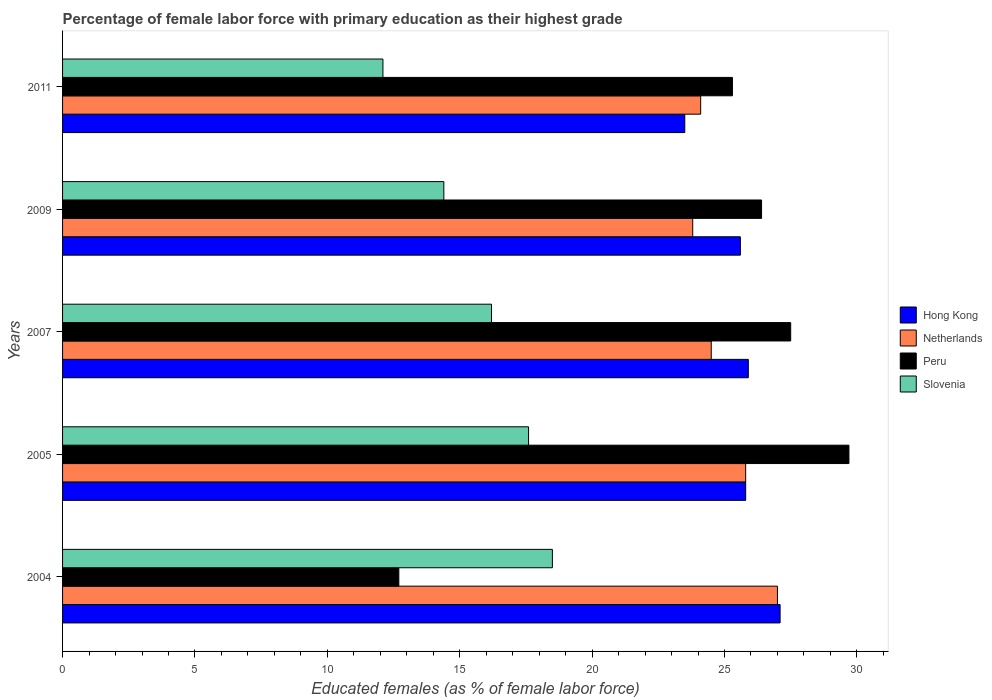How many different coloured bars are there?
Give a very brief answer. 4. How many groups of bars are there?
Your response must be concise. 5. Are the number of bars per tick equal to the number of legend labels?
Provide a short and direct response. Yes. Are the number of bars on each tick of the Y-axis equal?
Provide a succinct answer. Yes. How many bars are there on the 2nd tick from the bottom?
Your answer should be compact. 4. What is the percentage of female labor force with primary education in Netherlands in 2009?
Keep it short and to the point. 23.8. Across all years, what is the maximum percentage of female labor force with primary education in Peru?
Your answer should be compact. 29.7. Across all years, what is the minimum percentage of female labor force with primary education in Netherlands?
Your answer should be compact. 23.8. In which year was the percentage of female labor force with primary education in Slovenia minimum?
Provide a short and direct response. 2011. What is the total percentage of female labor force with primary education in Peru in the graph?
Ensure brevity in your answer.  121.6. What is the difference between the percentage of female labor force with primary education in Peru in 2004 and that in 2011?
Give a very brief answer. -12.6. What is the difference between the percentage of female labor force with primary education in Netherlands in 2005 and the percentage of female labor force with primary education in Hong Kong in 2007?
Your answer should be compact. -0.1. What is the average percentage of female labor force with primary education in Hong Kong per year?
Keep it short and to the point. 25.58. In the year 2009, what is the difference between the percentage of female labor force with primary education in Slovenia and percentage of female labor force with primary education in Hong Kong?
Your answer should be compact. -11.2. What is the ratio of the percentage of female labor force with primary education in Peru in 2005 to that in 2009?
Your response must be concise. 1.13. Is the difference between the percentage of female labor force with primary education in Slovenia in 2004 and 2005 greater than the difference between the percentage of female labor force with primary education in Hong Kong in 2004 and 2005?
Make the answer very short. No. What is the difference between the highest and the second highest percentage of female labor force with primary education in Hong Kong?
Keep it short and to the point. 1.2. What is the difference between the highest and the lowest percentage of female labor force with primary education in Netherlands?
Offer a terse response. 3.2. Is the sum of the percentage of female labor force with primary education in Peru in 2005 and 2009 greater than the maximum percentage of female labor force with primary education in Slovenia across all years?
Keep it short and to the point. Yes. What does the 2nd bar from the top in 2011 represents?
Your answer should be compact. Peru. What does the 4th bar from the bottom in 2005 represents?
Keep it short and to the point. Slovenia. Is it the case that in every year, the sum of the percentage of female labor force with primary education in Peru and percentage of female labor force with primary education in Netherlands is greater than the percentage of female labor force with primary education in Hong Kong?
Ensure brevity in your answer.  Yes. How many bars are there?
Give a very brief answer. 20. What is the difference between two consecutive major ticks on the X-axis?
Your answer should be very brief. 5. Does the graph contain any zero values?
Ensure brevity in your answer.  No. What is the title of the graph?
Ensure brevity in your answer.  Percentage of female labor force with primary education as their highest grade. Does "Guam" appear as one of the legend labels in the graph?
Provide a short and direct response. No. What is the label or title of the X-axis?
Your response must be concise. Educated females (as % of female labor force). What is the Educated females (as % of female labor force) of Hong Kong in 2004?
Keep it short and to the point. 27.1. What is the Educated females (as % of female labor force) in Peru in 2004?
Make the answer very short. 12.7. What is the Educated females (as % of female labor force) of Slovenia in 2004?
Keep it short and to the point. 18.5. What is the Educated females (as % of female labor force) of Hong Kong in 2005?
Provide a short and direct response. 25.8. What is the Educated females (as % of female labor force) in Netherlands in 2005?
Make the answer very short. 25.8. What is the Educated females (as % of female labor force) in Peru in 2005?
Provide a short and direct response. 29.7. What is the Educated females (as % of female labor force) of Slovenia in 2005?
Your answer should be compact. 17.6. What is the Educated females (as % of female labor force) of Hong Kong in 2007?
Your response must be concise. 25.9. What is the Educated females (as % of female labor force) in Netherlands in 2007?
Your answer should be very brief. 24.5. What is the Educated females (as % of female labor force) in Slovenia in 2007?
Offer a terse response. 16.2. What is the Educated females (as % of female labor force) in Hong Kong in 2009?
Offer a very short reply. 25.6. What is the Educated females (as % of female labor force) in Netherlands in 2009?
Offer a terse response. 23.8. What is the Educated females (as % of female labor force) of Peru in 2009?
Make the answer very short. 26.4. What is the Educated females (as % of female labor force) in Slovenia in 2009?
Keep it short and to the point. 14.4. What is the Educated females (as % of female labor force) of Netherlands in 2011?
Provide a short and direct response. 24.1. What is the Educated females (as % of female labor force) in Peru in 2011?
Your answer should be very brief. 25.3. What is the Educated females (as % of female labor force) of Slovenia in 2011?
Your answer should be very brief. 12.1. Across all years, what is the maximum Educated females (as % of female labor force) in Hong Kong?
Provide a short and direct response. 27.1. Across all years, what is the maximum Educated females (as % of female labor force) of Peru?
Make the answer very short. 29.7. Across all years, what is the minimum Educated females (as % of female labor force) of Netherlands?
Keep it short and to the point. 23.8. Across all years, what is the minimum Educated females (as % of female labor force) in Peru?
Provide a short and direct response. 12.7. Across all years, what is the minimum Educated females (as % of female labor force) of Slovenia?
Your response must be concise. 12.1. What is the total Educated females (as % of female labor force) in Hong Kong in the graph?
Make the answer very short. 127.9. What is the total Educated females (as % of female labor force) in Netherlands in the graph?
Make the answer very short. 125.2. What is the total Educated females (as % of female labor force) of Peru in the graph?
Provide a short and direct response. 121.6. What is the total Educated females (as % of female labor force) of Slovenia in the graph?
Offer a very short reply. 78.8. What is the difference between the Educated females (as % of female labor force) in Netherlands in 2004 and that in 2005?
Keep it short and to the point. 1.2. What is the difference between the Educated females (as % of female labor force) in Slovenia in 2004 and that in 2005?
Your answer should be compact. 0.9. What is the difference between the Educated females (as % of female labor force) of Hong Kong in 2004 and that in 2007?
Your response must be concise. 1.2. What is the difference between the Educated females (as % of female labor force) of Peru in 2004 and that in 2007?
Offer a very short reply. -14.8. What is the difference between the Educated females (as % of female labor force) of Hong Kong in 2004 and that in 2009?
Provide a short and direct response. 1.5. What is the difference between the Educated females (as % of female labor force) in Peru in 2004 and that in 2009?
Ensure brevity in your answer.  -13.7. What is the difference between the Educated females (as % of female labor force) in Hong Kong in 2004 and that in 2011?
Your answer should be compact. 3.6. What is the difference between the Educated females (as % of female labor force) of Netherlands in 2004 and that in 2011?
Provide a succinct answer. 2.9. What is the difference between the Educated females (as % of female labor force) of Peru in 2004 and that in 2011?
Make the answer very short. -12.6. What is the difference between the Educated females (as % of female labor force) in Slovenia in 2004 and that in 2011?
Make the answer very short. 6.4. What is the difference between the Educated females (as % of female labor force) in Netherlands in 2005 and that in 2007?
Give a very brief answer. 1.3. What is the difference between the Educated females (as % of female labor force) of Peru in 2005 and that in 2007?
Offer a very short reply. 2.2. What is the difference between the Educated females (as % of female labor force) in Slovenia in 2005 and that in 2007?
Offer a very short reply. 1.4. What is the difference between the Educated females (as % of female labor force) in Slovenia in 2005 and that in 2011?
Ensure brevity in your answer.  5.5. What is the difference between the Educated females (as % of female labor force) of Peru in 2007 and that in 2009?
Your answer should be very brief. 1.1. What is the difference between the Educated females (as % of female labor force) in Slovenia in 2007 and that in 2009?
Provide a succinct answer. 1.8. What is the difference between the Educated females (as % of female labor force) in Netherlands in 2007 and that in 2011?
Provide a succinct answer. 0.4. What is the difference between the Educated females (as % of female labor force) of Peru in 2007 and that in 2011?
Provide a succinct answer. 2.2. What is the difference between the Educated females (as % of female labor force) of Hong Kong in 2009 and that in 2011?
Give a very brief answer. 2.1. What is the difference between the Educated females (as % of female labor force) in Netherlands in 2009 and that in 2011?
Provide a short and direct response. -0.3. What is the difference between the Educated females (as % of female labor force) of Peru in 2009 and that in 2011?
Ensure brevity in your answer.  1.1. What is the difference between the Educated females (as % of female labor force) of Slovenia in 2009 and that in 2011?
Provide a short and direct response. 2.3. What is the difference between the Educated females (as % of female labor force) of Hong Kong in 2004 and the Educated females (as % of female labor force) of Netherlands in 2005?
Your answer should be very brief. 1.3. What is the difference between the Educated females (as % of female labor force) in Hong Kong in 2004 and the Educated females (as % of female labor force) in Peru in 2005?
Your response must be concise. -2.6. What is the difference between the Educated females (as % of female labor force) of Hong Kong in 2004 and the Educated females (as % of female labor force) of Slovenia in 2005?
Offer a very short reply. 9.5. What is the difference between the Educated females (as % of female labor force) in Hong Kong in 2004 and the Educated females (as % of female labor force) in Peru in 2007?
Make the answer very short. -0.4. What is the difference between the Educated females (as % of female labor force) in Netherlands in 2004 and the Educated females (as % of female labor force) in Peru in 2007?
Make the answer very short. -0.5. What is the difference between the Educated females (as % of female labor force) in Netherlands in 2004 and the Educated females (as % of female labor force) in Slovenia in 2007?
Keep it short and to the point. 10.8. What is the difference between the Educated females (as % of female labor force) in Peru in 2004 and the Educated females (as % of female labor force) in Slovenia in 2007?
Your response must be concise. -3.5. What is the difference between the Educated females (as % of female labor force) of Netherlands in 2004 and the Educated females (as % of female labor force) of Peru in 2009?
Offer a terse response. 0.6. What is the difference between the Educated females (as % of female labor force) in Netherlands in 2004 and the Educated females (as % of female labor force) in Slovenia in 2009?
Ensure brevity in your answer.  12.6. What is the difference between the Educated females (as % of female labor force) of Hong Kong in 2004 and the Educated females (as % of female labor force) of Netherlands in 2011?
Provide a short and direct response. 3. What is the difference between the Educated females (as % of female labor force) in Hong Kong in 2004 and the Educated females (as % of female labor force) in Peru in 2011?
Your response must be concise. 1.8. What is the difference between the Educated females (as % of female labor force) in Hong Kong in 2005 and the Educated females (as % of female labor force) in Netherlands in 2007?
Keep it short and to the point. 1.3. What is the difference between the Educated females (as % of female labor force) in Hong Kong in 2005 and the Educated females (as % of female labor force) in Slovenia in 2007?
Keep it short and to the point. 9.6. What is the difference between the Educated females (as % of female labor force) in Netherlands in 2005 and the Educated females (as % of female labor force) in Slovenia in 2007?
Offer a terse response. 9.6. What is the difference between the Educated females (as % of female labor force) of Peru in 2005 and the Educated females (as % of female labor force) of Slovenia in 2007?
Provide a short and direct response. 13.5. What is the difference between the Educated females (as % of female labor force) of Peru in 2005 and the Educated females (as % of female labor force) of Slovenia in 2009?
Ensure brevity in your answer.  15.3. What is the difference between the Educated females (as % of female labor force) of Hong Kong in 2005 and the Educated females (as % of female labor force) of Netherlands in 2011?
Provide a short and direct response. 1.7. What is the difference between the Educated females (as % of female labor force) of Netherlands in 2005 and the Educated females (as % of female labor force) of Peru in 2011?
Your answer should be very brief. 0.5. What is the difference between the Educated females (as % of female labor force) of Hong Kong in 2007 and the Educated females (as % of female labor force) of Netherlands in 2009?
Provide a short and direct response. 2.1. What is the difference between the Educated females (as % of female labor force) of Hong Kong in 2007 and the Educated females (as % of female labor force) of Peru in 2009?
Keep it short and to the point. -0.5. What is the difference between the Educated females (as % of female labor force) in Peru in 2007 and the Educated females (as % of female labor force) in Slovenia in 2009?
Give a very brief answer. 13.1. What is the difference between the Educated females (as % of female labor force) in Hong Kong in 2007 and the Educated females (as % of female labor force) in Netherlands in 2011?
Give a very brief answer. 1.8. What is the difference between the Educated females (as % of female labor force) of Hong Kong in 2007 and the Educated females (as % of female labor force) of Peru in 2011?
Your response must be concise. 0.6. What is the difference between the Educated females (as % of female labor force) of Netherlands in 2007 and the Educated females (as % of female labor force) of Slovenia in 2011?
Your response must be concise. 12.4. What is the difference between the Educated females (as % of female labor force) of Hong Kong in 2009 and the Educated females (as % of female labor force) of Netherlands in 2011?
Your answer should be compact. 1.5. What is the difference between the Educated females (as % of female labor force) in Hong Kong in 2009 and the Educated females (as % of female labor force) in Peru in 2011?
Your answer should be compact. 0.3. What is the difference between the Educated females (as % of female labor force) of Netherlands in 2009 and the Educated females (as % of female labor force) of Slovenia in 2011?
Your response must be concise. 11.7. What is the average Educated females (as % of female labor force) in Hong Kong per year?
Your response must be concise. 25.58. What is the average Educated females (as % of female labor force) in Netherlands per year?
Your answer should be very brief. 25.04. What is the average Educated females (as % of female labor force) in Peru per year?
Your response must be concise. 24.32. What is the average Educated females (as % of female labor force) of Slovenia per year?
Provide a short and direct response. 15.76. In the year 2004, what is the difference between the Educated females (as % of female labor force) in Hong Kong and Educated females (as % of female labor force) in Netherlands?
Offer a very short reply. 0.1. In the year 2004, what is the difference between the Educated females (as % of female labor force) of Hong Kong and Educated females (as % of female labor force) of Slovenia?
Offer a terse response. 8.6. In the year 2004, what is the difference between the Educated females (as % of female labor force) of Netherlands and Educated females (as % of female labor force) of Peru?
Ensure brevity in your answer.  14.3. In the year 2004, what is the difference between the Educated females (as % of female labor force) in Netherlands and Educated females (as % of female labor force) in Slovenia?
Provide a succinct answer. 8.5. In the year 2004, what is the difference between the Educated females (as % of female labor force) of Peru and Educated females (as % of female labor force) of Slovenia?
Provide a short and direct response. -5.8. In the year 2005, what is the difference between the Educated females (as % of female labor force) of Hong Kong and Educated females (as % of female labor force) of Netherlands?
Ensure brevity in your answer.  0. In the year 2005, what is the difference between the Educated females (as % of female labor force) of Netherlands and Educated females (as % of female labor force) of Peru?
Your answer should be very brief. -3.9. In the year 2007, what is the difference between the Educated females (as % of female labor force) of Hong Kong and Educated females (as % of female labor force) of Peru?
Your answer should be compact. -1.6. In the year 2007, what is the difference between the Educated females (as % of female labor force) in Hong Kong and Educated females (as % of female labor force) in Slovenia?
Your answer should be compact. 9.7. In the year 2007, what is the difference between the Educated females (as % of female labor force) in Netherlands and Educated females (as % of female labor force) in Slovenia?
Your answer should be very brief. 8.3. In the year 2007, what is the difference between the Educated females (as % of female labor force) of Peru and Educated females (as % of female labor force) of Slovenia?
Make the answer very short. 11.3. In the year 2009, what is the difference between the Educated females (as % of female labor force) in Hong Kong and Educated females (as % of female labor force) in Peru?
Keep it short and to the point. -0.8. In the year 2009, what is the difference between the Educated females (as % of female labor force) in Hong Kong and Educated females (as % of female labor force) in Slovenia?
Provide a succinct answer. 11.2. In the year 2009, what is the difference between the Educated females (as % of female labor force) of Netherlands and Educated females (as % of female labor force) of Peru?
Keep it short and to the point. -2.6. In the year 2009, what is the difference between the Educated females (as % of female labor force) in Netherlands and Educated females (as % of female labor force) in Slovenia?
Ensure brevity in your answer.  9.4. In the year 2009, what is the difference between the Educated females (as % of female labor force) of Peru and Educated females (as % of female labor force) of Slovenia?
Offer a very short reply. 12. In the year 2011, what is the difference between the Educated females (as % of female labor force) in Hong Kong and Educated females (as % of female labor force) in Netherlands?
Offer a very short reply. -0.6. In the year 2011, what is the difference between the Educated females (as % of female labor force) in Hong Kong and Educated females (as % of female labor force) in Slovenia?
Give a very brief answer. 11.4. In the year 2011, what is the difference between the Educated females (as % of female labor force) in Netherlands and Educated females (as % of female labor force) in Peru?
Provide a succinct answer. -1.2. In the year 2011, what is the difference between the Educated females (as % of female labor force) in Netherlands and Educated females (as % of female labor force) in Slovenia?
Your response must be concise. 12. What is the ratio of the Educated females (as % of female labor force) in Hong Kong in 2004 to that in 2005?
Offer a very short reply. 1.05. What is the ratio of the Educated females (as % of female labor force) in Netherlands in 2004 to that in 2005?
Make the answer very short. 1.05. What is the ratio of the Educated females (as % of female labor force) in Peru in 2004 to that in 2005?
Provide a short and direct response. 0.43. What is the ratio of the Educated females (as % of female labor force) of Slovenia in 2004 to that in 2005?
Give a very brief answer. 1.05. What is the ratio of the Educated females (as % of female labor force) of Hong Kong in 2004 to that in 2007?
Your response must be concise. 1.05. What is the ratio of the Educated females (as % of female labor force) of Netherlands in 2004 to that in 2007?
Your response must be concise. 1.1. What is the ratio of the Educated females (as % of female labor force) in Peru in 2004 to that in 2007?
Provide a short and direct response. 0.46. What is the ratio of the Educated females (as % of female labor force) in Slovenia in 2004 to that in 2007?
Keep it short and to the point. 1.14. What is the ratio of the Educated females (as % of female labor force) of Hong Kong in 2004 to that in 2009?
Provide a short and direct response. 1.06. What is the ratio of the Educated females (as % of female labor force) of Netherlands in 2004 to that in 2009?
Offer a very short reply. 1.13. What is the ratio of the Educated females (as % of female labor force) in Peru in 2004 to that in 2009?
Ensure brevity in your answer.  0.48. What is the ratio of the Educated females (as % of female labor force) of Slovenia in 2004 to that in 2009?
Offer a terse response. 1.28. What is the ratio of the Educated females (as % of female labor force) of Hong Kong in 2004 to that in 2011?
Offer a terse response. 1.15. What is the ratio of the Educated females (as % of female labor force) of Netherlands in 2004 to that in 2011?
Provide a short and direct response. 1.12. What is the ratio of the Educated females (as % of female labor force) in Peru in 2004 to that in 2011?
Provide a short and direct response. 0.5. What is the ratio of the Educated females (as % of female labor force) in Slovenia in 2004 to that in 2011?
Provide a succinct answer. 1.53. What is the ratio of the Educated females (as % of female labor force) in Hong Kong in 2005 to that in 2007?
Provide a succinct answer. 1. What is the ratio of the Educated females (as % of female labor force) of Netherlands in 2005 to that in 2007?
Your response must be concise. 1.05. What is the ratio of the Educated females (as % of female labor force) of Peru in 2005 to that in 2007?
Keep it short and to the point. 1.08. What is the ratio of the Educated females (as % of female labor force) in Slovenia in 2005 to that in 2007?
Your answer should be very brief. 1.09. What is the ratio of the Educated females (as % of female labor force) in Netherlands in 2005 to that in 2009?
Keep it short and to the point. 1.08. What is the ratio of the Educated females (as % of female labor force) in Peru in 2005 to that in 2009?
Ensure brevity in your answer.  1.12. What is the ratio of the Educated females (as % of female labor force) of Slovenia in 2005 to that in 2009?
Your response must be concise. 1.22. What is the ratio of the Educated females (as % of female labor force) of Hong Kong in 2005 to that in 2011?
Your answer should be very brief. 1.1. What is the ratio of the Educated females (as % of female labor force) in Netherlands in 2005 to that in 2011?
Make the answer very short. 1.07. What is the ratio of the Educated females (as % of female labor force) of Peru in 2005 to that in 2011?
Provide a short and direct response. 1.17. What is the ratio of the Educated females (as % of female labor force) in Slovenia in 2005 to that in 2011?
Keep it short and to the point. 1.45. What is the ratio of the Educated females (as % of female labor force) in Hong Kong in 2007 to that in 2009?
Your response must be concise. 1.01. What is the ratio of the Educated females (as % of female labor force) of Netherlands in 2007 to that in 2009?
Your answer should be very brief. 1.03. What is the ratio of the Educated females (as % of female labor force) in Peru in 2007 to that in 2009?
Give a very brief answer. 1.04. What is the ratio of the Educated females (as % of female labor force) in Slovenia in 2007 to that in 2009?
Your answer should be very brief. 1.12. What is the ratio of the Educated females (as % of female labor force) in Hong Kong in 2007 to that in 2011?
Ensure brevity in your answer.  1.1. What is the ratio of the Educated females (as % of female labor force) of Netherlands in 2007 to that in 2011?
Provide a short and direct response. 1.02. What is the ratio of the Educated females (as % of female labor force) of Peru in 2007 to that in 2011?
Keep it short and to the point. 1.09. What is the ratio of the Educated females (as % of female labor force) of Slovenia in 2007 to that in 2011?
Ensure brevity in your answer.  1.34. What is the ratio of the Educated females (as % of female labor force) of Hong Kong in 2009 to that in 2011?
Provide a short and direct response. 1.09. What is the ratio of the Educated females (as % of female labor force) of Netherlands in 2009 to that in 2011?
Offer a very short reply. 0.99. What is the ratio of the Educated females (as % of female labor force) in Peru in 2009 to that in 2011?
Give a very brief answer. 1.04. What is the ratio of the Educated females (as % of female labor force) in Slovenia in 2009 to that in 2011?
Your answer should be compact. 1.19. What is the difference between the highest and the second highest Educated females (as % of female labor force) of Hong Kong?
Keep it short and to the point. 1.2. What is the difference between the highest and the second highest Educated females (as % of female labor force) of Netherlands?
Your response must be concise. 1.2. What is the difference between the highest and the lowest Educated females (as % of female labor force) of Slovenia?
Give a very brief answer. 6.4. 